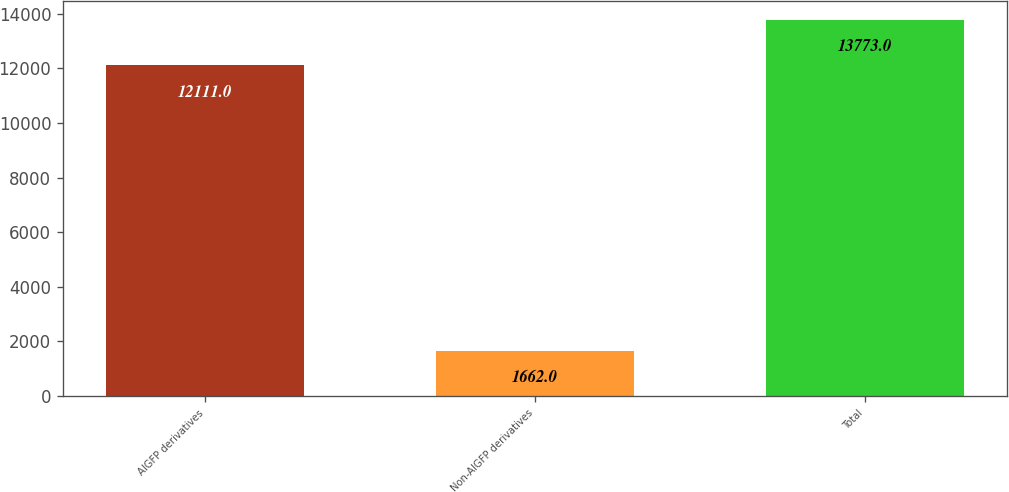Convert chart to OTSL. <chart><loc_0><loc_0><loc_500><loc_500><bar_chart><fcel>AIGFP derivatives<fcel>Non-AIGFP derivatives<fcel>Total<nl><fcel>12111<fcel>1662<fcel>13773<nl></chart> 